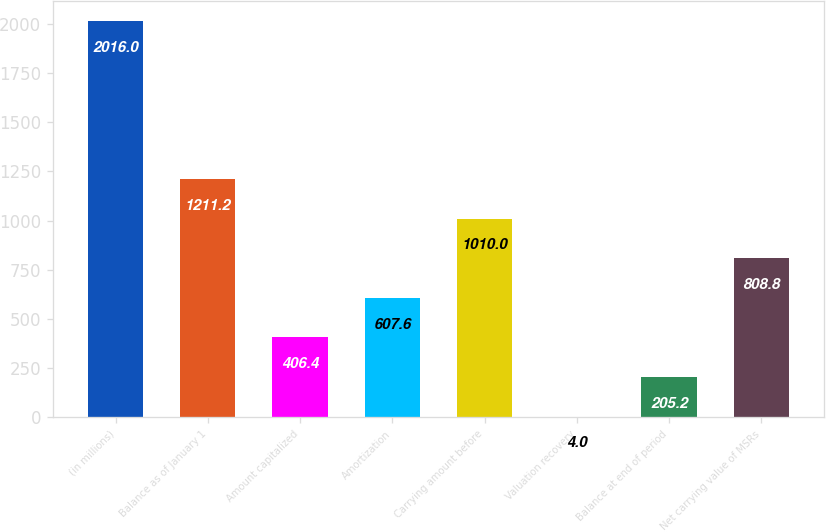Convert chart to OTSL. <chart><loc_0><loc_0><loc_500><loc_500><bar_chart><fcel>(in millions)<fcel>Balance as of January 1<fcel>Amount capitalized<fcel>Amortization<fcel>Carrying amount before<fcel>Valuation recovery<fcel>Balance at end of period<fcel>Net carrying value of MSRs<nl><fcel>2016<fcel>1211.2<fcel>406.4<fcel>607.6<fcel>1010<fcel>4<fcel>205.2<fcel>808.8<nl></chart> 